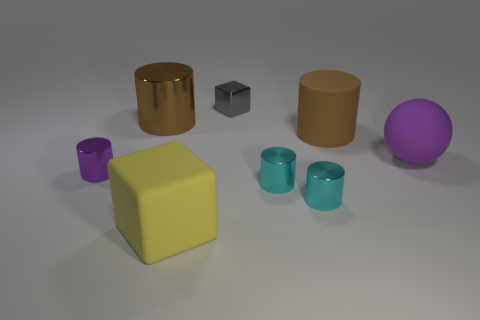Do the large rubber thing on the right side of the big brown rubber thing and the large brown metallic thing behind the purple metal cylinder have the same shape?
Make the answer very short. No. There is a brown object to the right of the large brown object to the left of the shiny cube; what is its shape?
Provide a succinct answer. Cylinder. What size is the matte thing that is both behind the yellow thing and on the left side of the purple rubber ball?
Your response must be concise. Large. There is a big brown metal object; is its shape the same as the matte object that is in front of the sphere?
Give a very brief answer. No. What size is the brown rubber thing that is the same shape as the small purple shiny thing?
Make the answer very short. Large. There is a big ball; is it the same color as the small object behind the brown metallic cylinder?
Provide a succinct answer. No. There is a small object that is to the left of the matte thing that is left of the rubber object that is behind the large purple thing; what is its shape?
Provide a succinct answer. Cylinder. There is a metallic block; is its size the same as the purple object that is on the left side of the big metallic thing?
Your answer should be very brief. Yes. What is the color of the rubber object that is both to the left of the big matte sphere and right of the big matte cube?
Give a very brief answer. Brown. What number of other objects are the same shape as the large purple matte object?
Offer a very short reply. 0. 